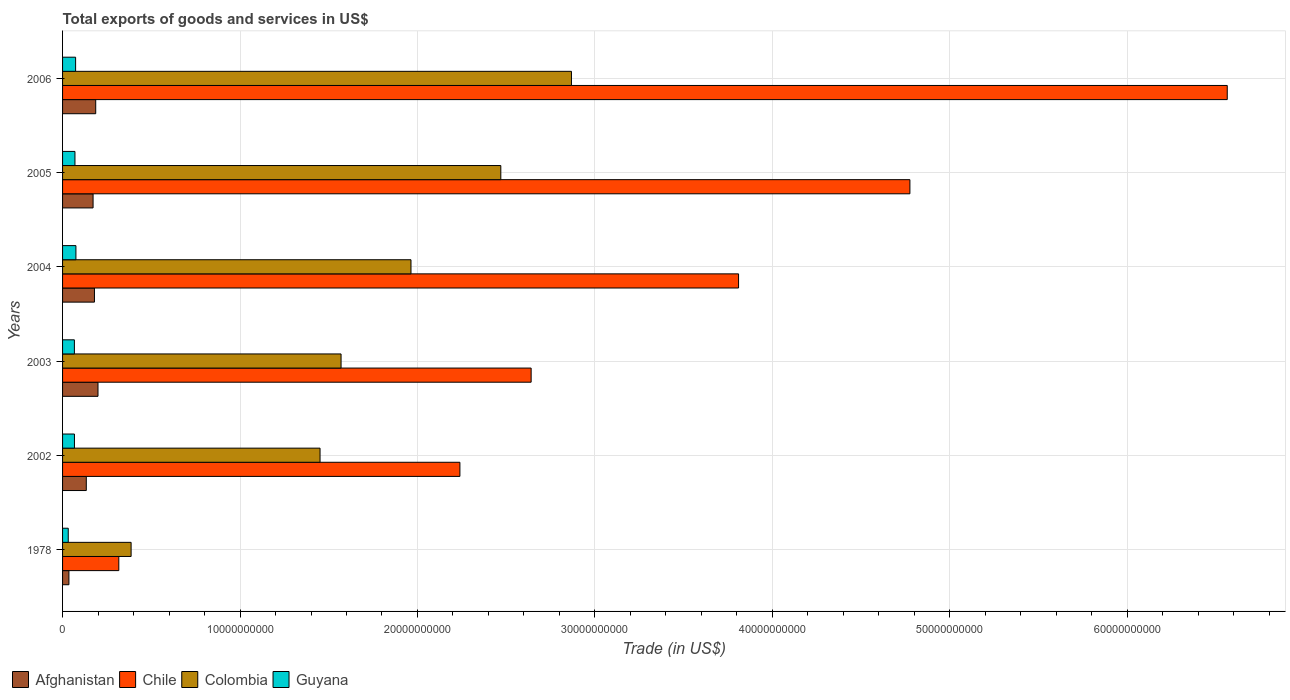How many groups of bars are there?
Your response must be concise. 6. Are the number of bars on each tick of the Y-axis equal?
Provide a succinct answer. Yes. How many bars are there on the 1st tick from the bottom?
Keep it short and to the point. 4. What is the label of the 3rd group of bars from the top?
Your answer should be very brief. 2004. In how many cases, is the number of bars for a given year not equal to the number of legend labels?
Offer a very short reply. 0. What is the total exports of goods and services in Guyana in 2005?
Your answer should be very brief. 6.98e+08. Across all years, what is the maximum total exports of goods and services in Chile?
Provide a succinct answer. 6.56e+1. Across all years, what is the minimum total exports of goods and services in Chile?
Offer a terse response. 3.17e+09. In which year was the total exports of goods and services in Afghanistan minimum?
Your answer should be very brief. 1978. What is the total total exports of goods and services in Colombia in the graph?
Ensure brevity in your answer.  1.07e+11. What is the difference between the total exports of goods and services in Chile in 2003 and that in 2005?
Make the answer very short. -2.13e+1. What is the difference between the total exports of goods and services in Colombia in 2005 and the total exports of goods and services in Chile in 2003?
Provide a short and direct response. -1.71e+09. What is the average total exports of goods and services in Chile per year?
Your response must be concise. 3.39e+1. In the year 2003, what is the difference between the total exports of goods and services in Colombia and total exports of goods and services in Afghanistan?
Provide a succinct answer. 1.37e+1. What is the ratio of the total exports of goods and services in Guyana in 2002 to that in 2004?
Your response must be concise. 0.89. Is the total exports of goods and services in Chile in 2003 less than that in 2006?
Your answer should be compact. Yes. What is the difference between the highest and the second highest total exports of goods and services in Chile?
Offer a terse response. 1.79e+1. What is the difference between the highest and the lowest total exports of goods and services in Chile?
Provide a short and direct response. 6.25e+1. Is the sum of the total exports of goods and services in Colombia in 2003 and 2006 greater than the maximum total exports of goods and services in Afghanistan across all years?
Give a very brief answer. Yes. Is it the case that in every year, the sum of the total exports of goods and services in Guyana and total exports of goods and services in Chile is greater than the sum of total exports of goods and services in Afghanistan and total exports of goods and services in Colombia?
Your answer should be compact. Yes. What does the 1st bar from the top in 2003 represents?
Provide a short and direct response. Guyana. What does the 4th bar from the bottom in 2006 represents?
Your response must be concise. Guyana. Is it the case that in every year, the sum of the total exports of goods and services in Afghanistan and total exports of goods and services in Guyana is greater than the total exports of goods and services in Chile?
Provide a succinct answer. No. How many bars are there?
Give a very brief answer. 24. How many years are there in the graph?
Offer a very short reply. 6. What is the difference between two consecutive major ticks on the X-axis?
Your response must be concise. 1.00e+1. Are the values on the major ticks of X-axis written in scientific E-notation?
Your answer should be very brief. No. Does the graph contain any zero values?
Your response must be concise. No. Does the graph contain grids?
Offer a terse response. Yes. Where does the legend appear in the graph?
Your answer should be very brief. Bottom left. What is the title of the graph?
Your response must be concise. Total exports of goods and services in US$. Does "Suriname" appear as one of the legend labels in the graph?
Your response must be concise. No. What is the label or title of the X-axis?
Ensure brevity in your answer.  Trade (in US$). What is the Trade (in US$) in Afghanistan in 1978?
Your response must be concise. 3.58e+08. What is the Trade (in US$) in Chile in 1978?
Make the answer very short. 3.17e+09. What is the Trade (in US$) of Colombia in 1978?
Give a very brief answer. 3.86e+09. What is the Trade (in US$) of Guyana in 1978?
Make the answer very short. 3.20e+08. What is the Trade (in US$) of Afghanistan in 2002?
Offer a very short reply. 1.34e+09. What is the Trade (in US$) in Chile in 2002?
Your response must be concise. 2.24e+1. What is the Trade (in US$) in Colombia in 2002?
Ensure brevity in your answer.  1.45e+1. What is the Trade (in US$) in Guyana in 2002?
Your answer should be very brief. 6.70e+08. What is the Trade (in US$) in Afghanistan in 2003?
Your response must be concise. 2.00e+09. What is the Trade (in US$) in Chile in 2003?
Your response must be concise. 2.64e+1. What is the Trade (in US$) in Colombia in 2003?
Your answer should be very brief. 1.57e+1. What is the Trade (in US$) of Guyana in 2003?
Provide a short and direct response. 6.66e+08. What is the Trade (in US$) of Afghanistan in 2004?
Keep it short and to the point. 1.80e+09. What is the Trade (in US$) of Chile in 2004?
Keep it short and to the point. 3.81e+1. What is the Trade (in US$) in Colombia in 2004?
Offer a terse response. 1.96e+1. What is the Trade (in US$) of Guyana in 2004?
Give a very brief answer. 7.53e+08. What is the Trade (in US$) of Afghanistan in 2005?
Give a very brief answer. 1.72e+09. What is the Trade (in US$) in Chile in 2005?
Provide a succinct answer. 4.77e+1. What is the Trade (in US$) in Colombia in 2005?
Keep it short and to the point. 2.47e+1. What is the Trade (in US$) in Guyana in 2005?
Your answer should be very brief. 6.98e+08. What is the Trade (in US$) of Afghanistan in 2006?
Offer a very short reply. 1.87e+09. What is the Trade (in US$) in Chile in 2006?
Offer a very short reply. 6.56e+1. What is the Trade (in US$) in Colombia in 2006?
Offer a terse response. 2.87e+1. What is the Trade (in US$) of Guyana in 2006?
Provide a short and direct response. 7.35e+08. Across all years, what is the maximum Trade (in US$) in Afghanistan?
Your answer should be very brief. 2.00e+09. Across all years, what is the maximum Trade (in US$) of Chile?
Provide a short and direct response. 6.56e+1. Across all years, what is the maximum Trade (in US$) of Colombia?
Give a very brief answer. 2.87e+1. Across all years, what is the maximum Trade (in US$) in Guyana?
Your answer should be compact. 7.53e+08. Across all years, what is the minimum Trade (in US$) of Afghanistan?
Give a very brief answer. 3.58e+08. Across all years, what is the minimum Trade (in US$) of Chile?
Your answer should be very brief. 3.17e+09. Across all years, what is the minimum Trade (in US$) of Colombia?
Provide a short and direct response. 3.86e+09. Across all years, what is the minimum Trade (in US$) of Guyana?
Ensure brevity in your answer.  3.20e+08. What is the total Trade (in US$) of Afghanistan in the graph?
Provide a short and direct response. 9.08e+09. What is the total Trade (in US$) in Chile in the graph?
Your response must be concise. 2.03e+11. What is the total Trade (in US$) in Colombia in the graph?
Give a very brief answer. 1.07e+11. What is the total Trade (in US$) of Guyana in the graph?
Give a very brief answer. 3.84e+09. What is the difference between the Trade (in US$) of Afghanistan in 1978 and that in 2002?
Give a very brief answer. -9.79e+08. What is the difference between the Trade (in US$) in Chile in 1978 and that in 2002?
Provide a short and direct response. -1.92e+1. What is the difference between the Trade (in US$) in Colombia in 1978 and that in 2002?
Make the answer very short. -1.06e+1. What is the difference between the Trade (in US$) in Guyana in 1978 and that in 2002?
Offer a very short reply. -3.50e+08. What is the difference between the Trade (in US$) in Afghanistan in 1978 and that in 2003?
Give a very brief answer. -1.64e+09. What is the difference between the Trade (in US$) of Chile in 1978 and that in 2003?
Provide a succinct answer. -2.32e+1. What is the difference between the Trade (in US$) of Colombia in 1978 and that in 2003?
Offer a very short reply. -1.18e+1. What is the difference between the Trade (in US$) in Guyana in 1978 and that in 2003?
Provide a succinct answer. -3.46e+08. What is the difference between the Trade (in US$) in Afghanistan in 1978 and that in 2004?
Provide a succinct answer. -1.44e+09. What is the difference between the Trade (in US$) in Chile in 1978 and that in 2004?
Provide a short and direct response. -3.49e+1. What is the difference between the Trade (in US$) in Colombia in 1978 and that in 2004?
Ensure brevity in your answer.  -1.58e+1. What is the difference between the Trade (in US$) of Guyana in 1978 and that in 2004?
Make the answer very short. -4.33e+08. What is the difference between the Trade (in US$) in Afghanistan in 1978 and that in 2005?
Offer a terse response. -1.36e+09. What is the difference between the Trade (in US$) in Chile in 1978 and that in 2005?
Your answer should be very brief. -4.46e+1. What is the difference between the Trade (in US$) in Colombia in 1978 and that in 2005?
Your response must be concise. -2.08e+1. What is the difference between the Trade (in US$) in Guyana in 1978 and that in 2005?
Keep it short and to the point. -3.78e+08. What is the difference between the Trade (in US$) in Afghanistan in 1978 and that in 2006?
Your response must be concise. -1.51e+09. What is the difference between the Trade (in US$) in Chile in 1978 and that in 2006?
Ensure brevity in your answer.  -6.25e+1. What is the difference between the Trade (in US$) of Colombia in 1978 and that in 2006?
Your response must be concise. -2.48e+1. What is the difference between the Trade (in US$) in Guyana in 1978 and that in 2006?
Offer a terse response. -4.15e+08. What is the difference between the Trade (in US$) in Afghanistan in 2002 and that in 2003?
Your answer should be compact. -6.59e+08. What is the difference between the Trade (in US$) of Chile in 2002 and that in 2003?
Your answer should be very brief. -4.01e+09. What is the difference between the Trade (in US$) of Colombia in 2002 and that in 2003?
Keep it short and to the point. -1.18e+09. What is the difference between the Trade (in US$) of Guyana in 2002 and that in 2003?
Ensure brevity in your answer.  3.89e+06. What is the difference between the Trade (in US$) of Afghanistan in 2002 and that in 2004?
Make the answer very short. -4.60e+08. What is the difference between the Trade (in US$) of Chile in 2002 and that in 2004?
Your answer should be very brief. -1.57e+1. What is the difference between the Trade (in US$) in Colombia in 2002 and that in 2004?
Keep it short and to the point. -5.12e+09. What is the difference between the Trade (in US$) in Guyana in 2002 and that in 2004?
Give a very brief answer. -8.26e+07. What is the difference between the Trade (in US$) of Afghanistan in 2002 and that in 2005?
Offer a very short reply. -3.82e+08. What is the difference between the Trade (in US$) in Chile in 2002 and that in 2005?
Your response must be concise. -2.54e+1. What is the difference between the Trade (in US$) in Colombia in 2002 and that in 2005?
Ensure brevity in your answer.  -1.02e+1. What is the difference between the Trade (in US$) of Guyana in 2002 and that in 2005?
Offer a terse response. -2.78e+07. What is the difference between the Trade (in US$) in Afghanistan in 2002 and that in 2006?
Your response must be concise. -5.31e+08. What is the difference between the Trade (in US$) in Chile in 2002 and that in 2006?
Provide a short and direct response. -4.32e+1. What is the difference between the Trade (in US$) of Colombia in 2002 and that in 2006?
Make the answer very short. -1.42e+1. What is the difference between the Trade (in US$) of Guyana in 2002 and that in 2006?
Give a very brief answer. -6.44e+07. What is the difference between the Trade (in US$) of Afghanistan in 2003 and that in 2004?
Your response must be concise. 2.00e+08. What is the difference between the Trade (in US$) of Chile in 2003 and that in 2004?
Provide a short and direct response. -1.17e+1. What is the difference between the Trade (in US$) of Colombia in 2003 and that in 2004?
Provide a short and direct response. -3.94e+09. What is the difference between the Trade (in US$) in Guyana in 2003 and that in 2004?
Provide a short and direct response. -8.65e+07. What is the difference between the Trade (in US$) of Afghanistan in 2003 and that in 2005?
Ensure brevity in your answer.  2.77e+08. What is the difference between the Trade (in US$) of Chile in 2003 and that in 2005?
Provide a succinct answer. -2.13e+1. What is the difference between the Trade (in US$) in Colombia in 2003 and that in 2005?
Offer a terse response. -9.00e+09. What is the difference between the Trade (in US$) of Guyana in 2003 and that in 2005?
Make the answer very short. -3.17e+07. What is the difference between the Trade (in US$) of Afghanistan in 2003 and that in 2006?
Your answer should be very brief. 1.28e+08. What is the difference between the Trade (in US$) of Chile in 2003 and that in 2006?
Your answer should be compact. -3.92e+1. What is the difference between the Trade (in US$) in Colombia in 2003 and that in 2006?
Your answer should be compact. -1.30e+1. What is the difference between the Trade (in US$) in Guyana in 2003 and that in 2006?
Make the answer very short. -6.83e+07. What is the difference between the Trade (in US$) in Afghanistan in 2004 and that in 2005?
Give a very brief answer. 7.78e+07. What is the difference between the Trade (in US$) in Chile in 2004 and that in 2005?
Give a very brief answer. -9.66e+09. What is the difference between the Trade (in US$) of Colombia in 2004 and that in 2005?
Provide a succinct answer. -5.06e+09. What is the difference between the Trade (in US$) of Guyana in 2004 and that in 2005?
Offer a very short reply. 5.48e+07. What is the difference between the Trade (in US$) of Afghanistan in 2004 and that in 2006?
Give a very brief answer. -7.13e+07. What is the difference between the Trade (in US$) in Chile in 2004 and that in 2006?
Make the answer very short. -2.75e+1. What is the difference between the Trade (in US$) of Colombia in 2004 and that in 2006?
Provide a succinct answer. -9.04e+09. What is the difference between the Trade (in US$) in Guyana in 2004 and that in 2006?
Offer a terse response. 1.82e+07. What is the difference between the Trade (in US$) in Afghanistan in 2005 and that in 2006?
Ensure brevity in your answer.  -1.49e+08. What is the difference between the Trade (in US$) of Chile in 2005 and that in 2006?
Your answer should be very brief. -1.79e+1. What is the difference between the Trade (in US$) in Colombia in 2005 and that in 2006?
Your response must be concise. -3.98e+09. What is the difference between the Trade (in US$) of Guyana in 2005 and that in 2006?
Your answer should be very brief. -3.66e+07. What is the difference between the Trade (in US$) of Afghanistan in 1978 and the Trade (in US$) of Chile in 2002?
Your response must be concise. -2.20e+1. What is the difference between the Trade (in US$) in Afghanistan in 1978 and the Trade (in US$) in Colombia in 2002?
Provide a short and direct response. -1.42e+1. What is the difference between the Trade (in US$) in Afghanistan in 1978 and the Trade (in US$) in Guyana in 2002?
Keep it short and to the point. -3.12e+08. What is the difference between the Trade (in US$) in Chile in 1978 and the Trade (in US$) in Colombia in 2002?
Give a very brief answer. -1.13e+1. What is the difference between the Trade (in US$) in Chile in 1978 and the Trade (in US$) in Guyana in 2002?
Your answer should be compact. 2.50e+09. What is the difference between the Trade (in US$) of Colombia in 1978 and the Trade (in US$) of Guyana in 2002?
Your answer should be compact. 3.19e+09. What is the difference between the Trade (in US$) of Afghanistan in 1978 and the Trade (in US$) of Chile in 2003?
Provide a short and direct response. -2.60e+1. What is the difference between the Trade (in US$) in Afghanistan in 1978 and the Trade (in US$) in Colombia in 2003?
Your answer should be very brief. -1.53e+1. What is the difference between the Trade (in US$) of Afghanistan in 1978 and the Trade (in US$) of Guyana in 2003?
Offer a terse response. -3.09e+08. What is the difference between the Trade (in US$) of Chile in 1978 and the Trade (in US$) of Colombia in 2003?
Offer a terse response. -1.25e+1. What is the difference between the Trade (in US$) in Chile in 1978 and the Trade (in US$) in Guyana in 2003?
Offer a terse response. 2.50e+09. What is the difference between the Trade (in US$) in Colombia in 1978 and the Trade (in US$) in Guyana in 2003?
Keep it short and to the point. 3.20e+09. What is the difference between the Trade (in US$) of Afghanistan in 1978 and the Trade (in US$) of Chile in 2004?
Provide a short and direct response. -3.77e+1. What is the difference between the Trade (in US$) in Afghanistan in 1978 and the Trade (in US$) in Colombia in 2004?
Give a very brief answer. -1.93e+1. What is the difference between the Trade (in US$) in Afghanistan in 1978 and the Trade (in US$) in Guyana in 2004?
Keep it short and to the point. -3.95e+08. What is the difference between the Trade (in US$) of Chile in 1978 and the Trade (in US$) of Colombia in 2004?
Give a very brief answer. -1.65e+1. What is the difference between the Trade (in US$) in Chile in 1978 and the Trade (in US$) in Guyana in 2004?
Offer a very short reply. 2.42e+09. What is the difference between the Trade (in US$) in Colombia in 1978 and the Trade (in US$) in Guyana in 2004?
Give a very brief answer. 3.11e+09. What is the difference between the Trade (in US$) of Afghanistan in 1978 and the Trade (in US$) of Chile in 2005?
Offer a terse response. -4.74e+1. What is the difference between the Trade (in US$) of Afghanistan in 1978 and the Trade (in US$) of Colombia in 2005?
Give a very brief answer. -2.43e+1. What is the difference between the Trade (in US$) of Afghanistan in 1978 and the Trade (in US$) of Guyana in 2005?
Ensure brevity in your answer.  -3.40e+08. What is the difference between the Trade (in US$) of Chile in 1978 and the Trade (in US$) of Colombia in 2005?
Make the answer very short. -2.15e+1. What is the difference between the Trade (in US$) in Chile in 1978 and the Trade (in US$) in Guyana in 2005?
Provide a short and direct response. 2.47e+09. What is the difference between the Trade (in US$) in Colombia in 1978 and the Trade (in US$) in Guyana in 2005?
Keep it short and to the point. 3.16e+09. What is the difference between the Trade (in US$) of Afghanistan in 1978 and the Trade (in US$) of Chile in 2006?
Give a very brief answer. -6.53e+1. What is the difference between the Trade (in US$) in Afghanistan in 1978 and the Trade (in US$) in Colombia in 2006?
Your answer should be very brief. -2.83e+1. What is the difference between the Trade (in US$) of Afghanistan in 1978 and the Trade (in US$) of Guyana in 2006?
Your response must be concise. -3.77e+08. What is the difference between the Trade (in US$) of Chile in 1978 and the Trade (in US$) of Colombia in 2006?
Provide a short and direct response. -2.55e+1. What is the difference between the Trade (in US$) of Chile in 1978 and the Trade (in US$) of Guyana in 2006?
Your answer should be compact. 2.43e+09. What is the difference between the Trade (in US$) of Colombia in 1978 and the Trade (in US$) of Guyana in 2006?
Keep it short and to the point. 3.13e+09. What is the difference between the Trade (in US$) of Afghanistan in 2002 and the Trade (in US$) of Chile in 2003?
Your response must be concise. -2.51e+1. What is the difference between the Trade (in US$) of Afghanistan in 2002 and the Trade (in US$) of Colombia in 2003?
Give a very brief answer. -1.44e+1. What is the difference between the Trade (in US$) of Afghanistan in 2002 and the Trade (in US$) of Guyana in 2003?
Make the answer very short. 6.71e+08. What is the difference between the Trade (in US$) in Chile in 2002 and the Trade (in US$) in Colombia in 2003?
Provide a succinct answer. 6.70e+09. What is the difference between the Trade (in US$) in Chile in 2002 and the Trade (in US$) in Guyana in 2003?
Provide a short and direct response. 2.17e+1. What is the difference between the Trade (in US$) in Colombia in 2002 and the Trade (in US$) in Guyana in 2003?
Your answer should be very brief. 1.38e+1. What is the difference between the Trade (in US$) of Afghanistan in 2002 and the Trade (in US$) of Chile in 2004?
Provide a short and direct response. -3.68e+1. What is the difference between the Trade (in US$) of Afghanistan in 2002 and the Trade (in US$) of Colombia in 2004?
Give a very brief answer. -1.83e+1. What is the difference between the Trade (in US$) of Afghanistan in 2002 and the Trade (in US$) of Guyana in 2004?
Ensure brevity in your answer.  5.84e+08. What is the difference between the Trade (in US$) of Chile in 2002 and the Trade (in US$) of Colombia in 2004?
Ensure brevity in your answer.  2.76e+09. What is the difference between the Trade (in US$) in Chile in 2002 and the Trade (in US$) in Guyana in 2004?
Keep it short and to the point. 2.16e+1. What is the difference between the Trade (in US$) in Colombia in 2002 and the Trade (in US$) in Guyana in 2004?
Provide a succinct answer. 1.38e+1. What is the difference between the Trade (in US$) of Afghanistan in 2002 and the Trade (in US$) of Chile in 2005?
Offer a terse response. -4.64e+1. What is the difference between the Trade (in US$) of Afghanistan in 2002 and the Trade (in US$) of Colombia in 2005?
Offer a terse response. -2.34e+1. What is the difference between the Trade (in US$) in Afghanistan in 2002 and the Trade (in US$) in Guyana in 2005?
Offer a terse response. 6.39e+08. What is the difference between the Trade (in US$) in Chile in 2002 and the Trade (in US$) in Colombia in 2005?
Make the answer very short. -2.31e+09. What is the difference between the Trade (in US$) in Chile in 2002 and the Trade (in US$) in Guyana in 2005?
Give a very brief answer. 2.17e+1. What is the difference between the Trade (in US$) of Colombia in 2002 and the Trade (in US$) of Guyana in 2005?
Offer a terse response. 1.38e+1. What is the difference between the Trade (in US$) in Afghanistan in 2002 and the Trade (in US$) in Chile in 2006?
Offer a terse response. -6.43e+1. What is the difference between the Trade (in US$) of Afghanistan in 2002 and the Trade (in US$) of Colombia in 2006?
Make the answer very short. -2.73e+1. What is the difference between the Trade (in US$) in Afghanistan in 2002 and the Trade (in US$) in Guyana in 2006?
Offer a terse response. 6.03e+08. What is the difference between the Trade (in US$) in Chile in 2002 and the Trade (in US$) in Colombia in 2006?
Your answer should be very brief. -6.29e+09. What is the difference between the Trade (in US$) of Chile in 2002 and the Trade (in US$) of Guyana in 2006?
Make the answer very short. 2.17e+1. What is the difference between the Trade (in US$) in Colombia in 2002 and the Trade (in US$) in Guyana in 2006?
Keep it short and to the point. 1.38e+1. What is the difference between the Trade (in US$) of Afghanistan in 2003 and the Trade (in US$) of Chile in 2004?
Keep it short and to the point. -3.61e+1. What is the difference between the Trade (in US$) of Afghanistan in 2003 and the Trade (in US$) of Colombia in 2004?
Provide a succinct answer. -1.76e+1. What is the difference between the Trade (in US$) of Afghanistan in 2003 and the Trade (in US$) of Guyana in 2004?
Give a very brief answer. 1.24e+09. What is the difference between the Trade (in US$) in Chile in 2003 and the Trade (in US$) in Colombia in 2004?
Keep it short and to the point. 6.77e+09. What is the difference between the Trade (in US$) of Chile in 2003 and the Trade (in US$) of Guyana in 2004?
Offer a very short reply. 2.57e+1. What is the difference between the Trade (in US$) of Colombia in 2003 and the Trade (in US$) of Guyana in 2004?
Make the answer very short. 1.49e+1. What is the difference between the Trade (in US$) in Afghanistan in 2003 and the Trade (in US$) in Chile in 2005?
Ensure brevity in your answer.  -4.58e+1. What is the difference between the Trade (in US$) in Afghanistan in 2003 and the Trade (in US$) in Colombia in 2005?
Ensure brevity in your answer.  -2.27e+1. What is the difference between the Trade (in US$) of Afghanistan in 2003 and the Trade (in US$) of Guyana in 2005?
Keep it short and to the point. 1.30e+09. What is the difference between the Trade (in US$) in Chile in 2003 and the Trade (in US$) in Colombia in 2005?
Give a very brief answer. 1.71e+09. What is the difference between the Trade (in US$) of Chile in 2003 and the Trade (in US$) of Guyana in 2005?
Your answer should be compact. 2.57e+1. What is the difference between the Trade (in US$) in Colombia in 2003 and the Trade (in US$) in Guyana in 2005?
Your response must be concise. 1.50e+1. What is the difference between the Trade (in US$) of Afghanistan in 2003 and the Trade (in US$) of Chile in 2006?
Offer a terse response. -6.36e+1. What is the difference between the Trade (in US$) of Afghanistan in 2003 and the Trade (in US$) of Colombia in 2006?
Your response must be concise. -2.67e+1. What is the difference between the Trade (in US$) of Afghanistan in 2003 and the Trade (in US$) of Guyana in 2006?
Your answer should be very brief. 1.26e+09. What is the difference between the Trade (in US$) of Chile in 2003 and the Trade (in US$) of Colombia in 2006?
Provide a succinct answer. -2.27e+09. What is the difference between the Trade (in US$) in Chile in 2003 and the Trade (in US$) in Guyana in 2006?
Make the answer very short. 2.57e+1. What is the difference between the Trade (in US$) of Colombia in 2003 and the Trade (in US$) of Guyana in 2006?
Ensure brevity in your answer.  1.50e+1. What is the difference between the Trade (in US$) of Afghanistan in 2004 and the Trade (in US$) of Chile in 2005?
Provide a succinct answer. -4.60e+1. What is the difference between the Trade (in US$) of Afghanistan in 2004 and the Trade (in US$) of Colombia in 2005?
Provide a short and direct response. -2.29e+1. What is the difference between the Trade (in US$) in Afghanistan in 2004 and the Trade (in US$) in Guyana in 2005?
Your response must be concise. 1.10e+09. What is the difference between the Trade (in US$) in Chile in 2004 and the Trade (in US$) in Colombia in 2005?
Your answer should be very brief. 1.34e+1. What is the difference between the Trade (in US$) of Chile in 2004 and the Trade (in US$) of Guyana in 2005?
Give a very brief answer. 3.74e+1. What is the difference between the Trade (in US$) of Colombia in 2004 and the Trade (in US$) of Guyana in 2005?
Your answer should be compact. 1.89e+1. What is the difference between the Trade (in US$) of Afghanistan in 2004 and the Trade (in US$) of Chile in 2006?
Give a very brief answer. -6.38e+1. What is the difference between the Trade (in US$) of Afghanistan in 2004 and the Trade (in US$) of Colombia in 2006?
Your response must be concise. -2.69e+1. What is the difference between the Trade (in US$) of Afghanistan in 2004 and the Trade (in US$) of Guyana in 2006?
Your response must be concise. 1.06e+09. What is the difference between the Trade (in US$) in Chile in 2004 and the Trade (in US$) in Colombia in 2006?
Offer a very short reply. 9.42e+09. What is the difference between the Trade (in US$) in Chile in 2004 and the Trade (in US$) in Guyana in 2006?
Your answer should be compact. 3.74e+1. What is the difference between the Trade (in US$) in Colombia in 2004 and the Trade (in US$) in Guyana in 2006?
Offer a terse response. 1.89e+1. What is the difference between the Trade (in US$) of Afghanistan in 2005 and the Trade (in US$) of Chile in 2006?
Your answer should be compact. -6.39e+1. What is the difference between the Trade (in US$) of Afghanistan in 2005 and the Trade (in US$) of Colombia in 2006?
Your answer should be very brief. -2.70e+1. What is the difference between the Trade (in US$) of Afghanistan in 2005 and the Trade (in US$) of Guyana in 2006?
Provide a short and direct response. 9.84e+08. What is the difference between the Trade (in US$) of Chile in 2005 and the Trade (in US$) of Colombia in 2006?
Offer a very short reply. 1.91e+1. What is the difference between the Trade (in US$) in Chile in 2005 and the Trade (in US$) in Guyana in 2006?
Your response must be concise. 4.70e+1. What is the difference between the Trade (in US$) in Colombia in 2005 and the Trade (in US$) in Guyana in 2006?
Provide a succinct answer. 2.40e+1. What is the average Trade (in US$) of Afghanistan per year?
Keep it short and to the point. 1.51e+09. What is the average Trade (in US$) of Chile per year?
Keep it short and to the point. 3.39e+1. What is the average Trade (in US$) of Colombia per year?
Offer a very short reply. 1.78e+1. What is the average Trade (in US$) of Guyana per year?
Ensure brevity in your answer.  6.40e+08. In the year 1978, what is the difference between the Trade (in US$) in Afghanistan and Trade (in US$) in Chile?
Offer a terse response. -2.81e+09. In the year 1978, what is the difference between the Trade (in US$) of Afghanistan and Trade (in US$) of Colombia?
Provide a short and direct response. -3.50e+09. In the year 1978, what is the difference between the Trade (in US$) of Afghanistan and Trade (in US$) of Guyana?
Offer a very short reply. 3.79e+07. In the year 1978, what is the difference between the Trade (in US$) in Chile and Trade (in US$) in Colombia?
Provide a short and direct response. -6.93e+08. In the year 1978, what is the difference between the Trade (in US$) of Chile and Trade (in US$) of Guyana?
Offer a very short reply. 2.85e+09. In the year 1978, what is the difference between the Trade (in US$) in Colombia and Trade (in US$) in Guyana?
Your answer should be compact. 3.54e+09. In the year 2002, what is the difference between the Trade (in US$) of Afghanistan and Trade (in US$) of Chile?
Ensure brevity in your answer.  -2.11e+1. In the year 2002, what is the difference between the Trade (in US$) in Afghanistan and Trade (in US$) in Colombia?
Your response must be concise. -1.32e+1. In the year 2002, what is the difference between the Trade (in US$) in Afghanistan and Trade (in US$) in Guyana?
Offer a very short reply. 6.67e+08. In the year 2002, what is the difference between the Trade (in US$) of Chile and Trade (in US$) of Colombia?
Offer a very short reply. 7.88e+09. In the year 2002, what is the difference between the Trade (in US$) in Chile and Trade (in US$) in Guyana?
Offer a very short reply. 2.17e+1. In the year 2002, what is the difference between the Trade (in US$) of Colombia and Trade (in US$) of Guyana?
Your answer should be very brief. 1.38e+1. In the year 2003, what is the difference between the Trade (in US$) in Afghanistan and Trade (in US$) in Chile?
Make the answer very short. -2.44e+1. In the year 2003, what is the difference between the Trade (in US$) of Afghanistan and Trade (in US$) of Colombia?
Provide a succinct answer. -1.37e+1. In the year 2003, what is the difference between the Trade (in US$) of Afghanistan and Trade (in US$) of Guyana?
Offer a very short reply. 1.33e+09. In the year 2003, what is the difference between the Trade (in US$) in Chile and Trade (in US$) in Colombia?
Your answer should be compact. 1.07e+1. In the year 2003, what is the difference between the Trade (in US$) of Chile and Trade (in US$) of Guyana?
Keep it short and to the point. 2.57e+1. In the year 2003, what is the difference between the Trade (in US$) of Colombia and Trade (in US$) of Guyana?
Keep it short and to the point. 1.50e+1. In the year 2004, what is the difference between the Trade (in US$) of Afghanistan and Trade (in US$) of Chile?
Your response must be concise. -3.63e+1. In the year 2004, what is the difference between the Trade (in US$) of Afghanistan and Trade (in US$) of Colombia?
Provide a succinct answer. -1.78e+1. In the year 2004, what is the difference between the Trade (in US$) of Afghanistan and Trade (in US$) of Guyana?
Your answer should be very brief. 1.04e+09. In the year 2004, what is the difference between the Trade (in US$) in Chile and Trade (in US$) in Colombia?
Your answer should be compact. 1.85e+1. In the year 2004, what is the difference between the Trade (in US$) of Chile and Trade (in US$) of Guyana?
Keep it short and to the point. 3.73e+1. In the year 2004, what is the difference between the Trade (in US$) of Colombia and Trade (in US$) of Guyana?
Offer a terse response. 1.89e+1. In the year 2005, what is the difference between the Trade (in US$) of Afghanistan and Trade (in US$) of Chile?
Provide a short and direct response. -4.60e+1. In the year 2005, what is the difference between the Trade (in US$) of Afghanistan and Trade (in US$) of Colombia?
Your response must be concise. -2.30e+1. In the year 2005, what is the difference between the Trade (in US$) of Afghanistan and Trade (in US$) of Guyana?
Your answer should be very brief. 1.02e+09. In the year 2005, what is the difference between the Trade (in US$) of Chile and Trade (in US$) of Colombia?
Give a very brief answer. 2.31e+1. In the year 2005, what is the difference between the Trade (in US$) of Chile and Trade (in US$) of Guyana?
Offer a terse response. 4.71e+1. In the year 2005, what is the difference between the Trade (in US$) in Colombia and Trade (in US$) in Guyana?
Provide a short and direct response. 2.40e+1. In the year 2006, what is the difference between the Trade (in US$) of Afghanistan and Trade (in US$) of Chile?
Your answer should be compact. -6.38e+1. In the year 2006, what is the difference between the Trade (in US$) in Afghanistan and Trade (in US$) in Colombia?
Your answer should be very brief. -2.68e+1. In the year 2006, what is the difference between the Trade (in US$) in Afghanistan and Trade (in US$) in Guyana?
Provide a short and direct response. 1.13e+09. In the year 2006, what is the difference between the Trade (in US$) of Chile and Trade (in US$) of Colombia?
Offer a terse response. 3.70e+1. In the year 2006, what is the difference between the Trade (in US$) of Chile and Trade (in US$) of Guyana?
Your answer should be compact. 6.49e+1. In the year 2006, what is the difference between the Trade (in US$) in Colombia and Trade (in US$) in Guyana?
Give a very brief answer. 2.79e+1. What is the ratio of the Trade (in US$) in Afghanistan in 1978 to that in 2002?
Keep it short and to the point. 0.27. What is the ratio of the Trade (in US$) of Chile in 1978 to that in 2002?
Keep it short and to the point. 0.14. What is the ratio of the Trade (in US$) of Colombia in 1978 to that in 2002?
Keep it short and to the point. 0.27. What is the ratio of the Trade (in US$) in Guyana in 1978 to that in 2002?
Provide a succinct answer. 0.48. What is the ratio of the Trade (in US$) of Afghanistan in 1978 to that in 2003?
Offer a very short reply. 0.18. What is the ratio of the Trade (in US$) in Chile in 1978 to that in 2003?
Provide a short and direct response. 0.12. What is the ratio of the Trade (in US$) of Colombia in 1978 to that in 2003?
Your answer should be very brief. 0.25. What is the ratio of the Trade (in US$) in Guyana in 1978 to that in 2003?
Keep it short and to the point. 0.48. What is the ratio of the Trade (in US$) of Afghanistan in 1978 to that in 2004?
Keep it short and to the point. 0.2. What is the ratio of the Trade (in US$) in Chile in 1978 to that in 2004?
Offer a terse response. 0.08. What is the ratio of the Trade (in US$) of Colombia in 1978 to that in 2004?
Your answer should be very brief. 0.2. What is the ratio of the Trade (in US$) of Guyana in 1978 to that in 2004?
Ensure brevity in your answer.  0.42. What is the ratio of the Trade (in US$) of Afghanistan in 1978 to that in 2005?
Your response must be concise. 0.21. What is the ratio of the Trade (in US$) in Chile in 1978 to that in 2005?
Provide a short and direct response. 0.07. What is the ratio of the Trade (in US$) in Colombia in 1978 to that in 2005?
Your answer should be compact. 0.16. What is the ratio of the Trade (in US$) in Guyana in 1978 to that in 2005?
Make the answer very short. 0.46. What is the ratio of the Trade (in US$) of Afghanistan in 1978 to that in 2006?
Provide a short and direct response. 0.19. What is the ratio of the Trade (in US$) in Chile in 1978 to that in 2006?
Provide a succinct answer. 0.05. What is the ratio of the Trade (in US$) in Colombia in 1978 to that in 2006?
Your answer should be compact. 0.13. What is the ratio of the Trade (in US$) in Guyana in 1978 to that in 2006?
Provide a short and direct response. 0.44. What is the ratio of the Trade (in US$) in Afghanistan in 2002 to that in 2003?
Offer a very short reply. 0.67. What is the ratio of the Trade (in US$) in Chile in 2002 to that in 2003?
Your answer should be compact. 0.85. What is the ratio of the Trade (in US$) of Colombia in 2002 to that in 2003?
Ensure brevity in your answer.  0.92. What is the ratio of the Trade (in US$) of Afghanistan in 2002 to that in 2004?
Give a very brief answer. 0.74. What is the ratio of the Trade (in US$) in Chile in 2002 to that in 2004?
Offer a very short reply. 0.59. What is the ratio of the Trade (in US$) in Colombia in 2002 to that in 2004?
Your answer should be compact. 0.74. What is the ratio of the Trade (in US$) in Guyana in 2002 to that in 2004?
Your response must be concise. 0.89. What is the ratio of the Trade (in US$) of Afghanistan in 2002 to that in 2005?
Offer a terse response. 0.78. What is the ratio of the Trade (in US$) in Chile in 2002 to that in 2005?
Ensure brevity in your answer.  0.47. What is the ratio of the Trade (in US$) in Colombia in 2002 to that in 2005?
Offer a terse response. 0.59. What is the ratio of the Trade (in US$) in Guyana in 2002 to that in 2005?
Your response must be concise. 0.96. What is the ratio of the Trade (in US$) in Afghanistan in 2002 to that in 2006?
Provide a short and direct response. 0.72. What is the ratio of the Trade (in US$) in Chile in 2002 to that in 2006?
Provide a succinct answer. 0.34. What is the ratio of the Trade (in US$) of Colombia in 2002 to that in 2006?
Offer a terse response. 0.51. What is the ratio of the Trade (in US$) of Guyana in 2002 to that in 2006?
Give a very brief answer. 0.91. What is the ratio of the Trade (in US$) in Afghanistan in 2003 to that in 2004?
Keep it short and to the point. 1.11. What is the ratio of the Trade (in US$) in Chile in 2003 to that in 2004?
Offer a very short reply. 0.69. What is the ratio of the Trade (in US$) of Colombia in 2003 to that in 2004?
Provide a succinct answer. 0.8. What is the ratio of the Trade (in US$) in Guyana in 2003 to that in 2004?
Ensure brevity in your answer.  0.89. What is the ratio of the Trade (in US$) in Afghanistan in 2003 to that in 2005?
Ensure brevity in your answer.  1.16. What is the ratio of the Trade (in US$) in Chile in 2003 to that in 2005?
Your answer should be very brief. 0.55. What is the ratio of the Trade (in US$) of Colombia in 2003 to that in 2005?
Make the answer very short. 0.64. What is the ratio of the Trade (in US$) of Guyana in 2003 to that in 2005?
Provide a short and direct response. 0.95. What is the ratio of the Trade (in US$) of Afghanistan in 2003 to that in 2006?
Give a very brief answer. 1.07. What is the ratio of the Trade (in US$) of Chile in 2003 to that in 2006?
Provide a short and direct response. 0.4. What is the ratio of the Trade (in US$) of Colombia in 2003 to that in 2006?
Your answer should be compact. 0.55. What is the ratio of the Trade (in US$) of Guyana in 2003 to that in 2006?
Give a very brief answer. 0.91. What is the ratio of the Trade (in US$) in Afghanistan in 2004 to that in 2005?
Offer a very short reply. 1.05. What is the ratio of the Trade (in US$) in Chile in 2004 to that in 2005?
Provide a short and direct response. 0.8. What is the ratio of the Trade (in US$) of Colombia in 2004 to that in 2005?
Your answer should be compact. 0.8. What is the ratio of the Trade (in US$) of Guyana in 2004 to that in 2005?
Ensure brevity in your answer.  1.08. What is the ratio of the Trade (in US$) in Afghanistan in 2004 to that in 2006?
Ensure brevity in your answer.  0.96. What is the ratio of the Trade (in US$) in Chile in 2004 to that in 2006?
Your answer should be very brief. 0.58. What is the ratio of the Trade (in US$) of Colombia in 2004 to that in 2006?
Your response must be concise. 0.68. What is the ratio of the Trade (in US$) of Guyana in 2004 to that in 2006?
Offer a terse response. 1.02. What is the ratio of the Trade (in US$) of Afghanistan in 2005 to that in 2006?
Give a very brief answer. 0.92. What is the ratio of the Trade (in US$) of Chile in 2005 to that in 2006?
Provide a short and direct response. 0.73. What is the ratio of the Trade (in US$) of Colombia in 2005 to that in 2006?
Provide a succinct answer. 0.86. What is the ratio of the Trade (in US$) in Guyana in 2005 to that in 2006?
Your answer should be very brief. 0.95. What is the difference between the highest and the second highest Trade (in US$) in Afghanistan?
Make the answer very short. 1.28e+08. What is the difference between the highest and the second highest Trade (in US$) of Chile?
Make the answer very short. 1.79e+1. What is the difference between the highest and the second highest Trade (in US$) in Colombia?
Your response must be concise. 3.98e+09. What is the difference between the highest and the second highest Trade (in US$) of Guyana?
Offer a terse response. 1.82e+07. What is the difference between the highest and the lowest Trade (in US$) in Afghanistan?
Provide a succinct answer. 1.64e+09. What is the difference between the highest and the lowest Trade (in US$) of Chile?
Offer a very short reply. 6.25e+1. What is the difference between the highest and the lowest Trade (in US$) in Colombia?
Keep it short and to the point. 2.48e+1. What is the difference between the highest and the lowest Trade (in US$) in Guyana?
Offer a very short reply. 4.33e+08. 